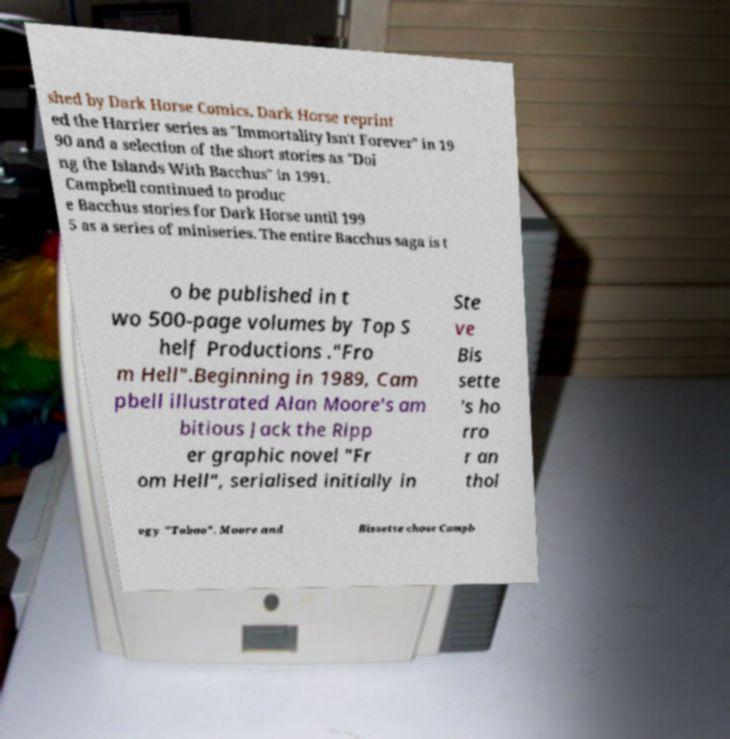There's text embedded in this image that I need extracted. Can you transcribe it verbatim? shed by Dark Horse Comics. Dark Horse reprint ed the Harrier series as "Immortality Isn't Forever" in 19 90 and a selection of the short stories as "Doi ng the Islands With Bacchus" in 1991. Campbell continued to produc e Bacchus stories for Dark Horse until 199 5 as a series of miniseries. The entire Bacchus saga is t o be published in t wo 500-page volumes by Top S helf Productions ."Fro m Hell".Beginning in 1989, Cam pbell illustrated Alan Moore's am bitious Jack the Ripp er graphic novel "Fr om Hell", serialised initially in Ste ve Bis sette 's ho rro r an thol ogy "Taboo". Moore and Bissette chose Campb 